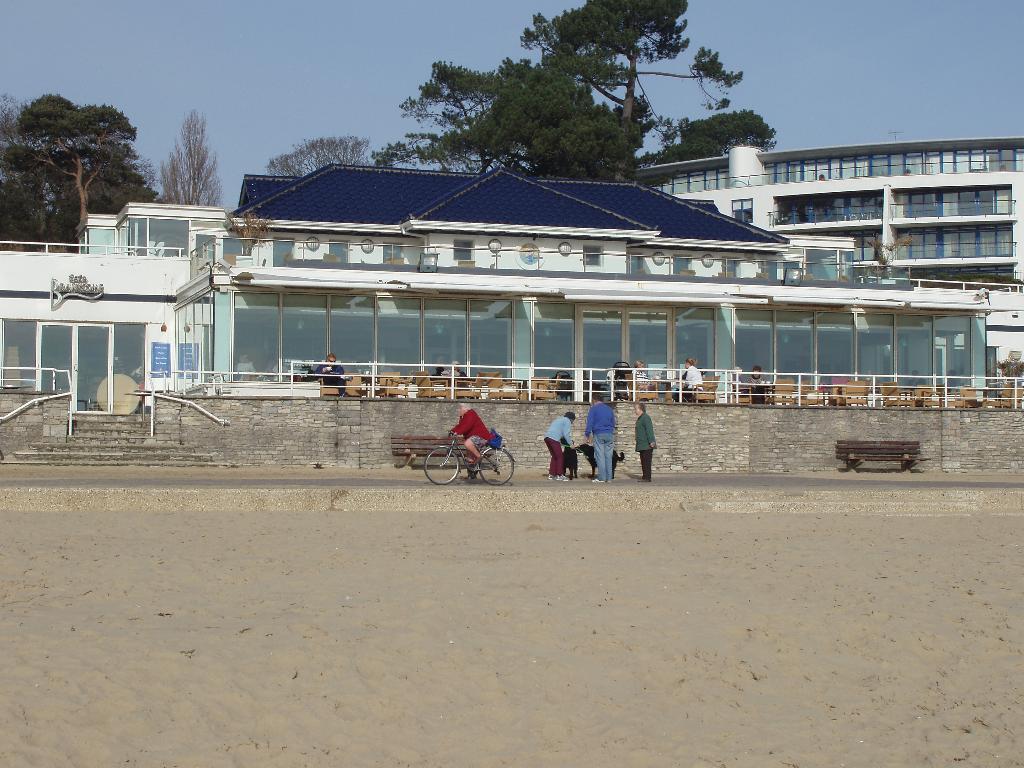Describe this image in one or two sentences. In this picture we can observe some people on the road. There is a dog. We can observe a person cycling a bicycle. We can observe buildings and trees. In the background there is a sky. 